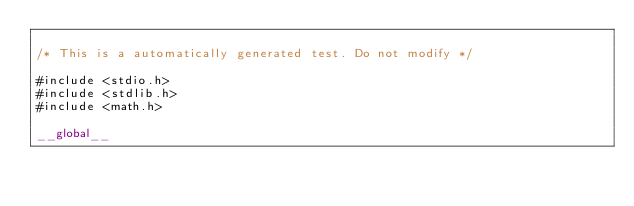<code> <loc_0><loc_0><loc_500><loc_500><_Cuda_>
/* This is a automatically generated test. Do not modify */

#include <stdio.h>
#include <stdlib.h>
#include <math.h>

__global__</code> 